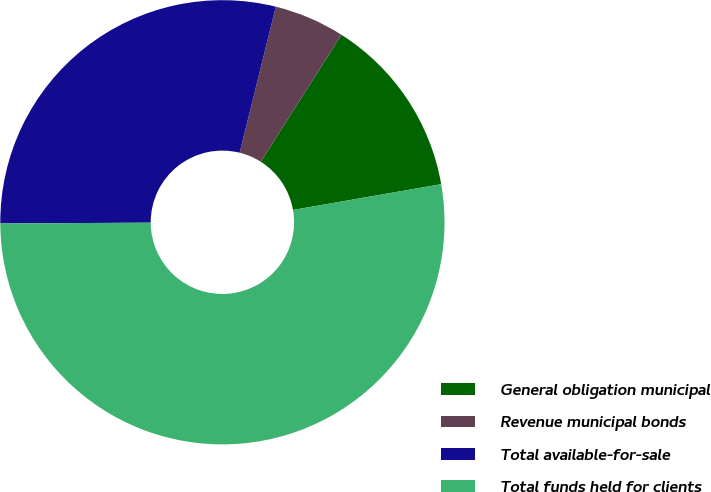<chart> <loc_0><loc_0><loc_500><loc_500><pie_chart><fcel>General obligation municipal<fcel>Revenue municipal bonds<fcel>Total available-for-sale<fcel>Total funds held for clients<nl><fcel>13.25%<fcel>5.14%<fcel>28.95%<fcel>52.66%<nl></chart> 